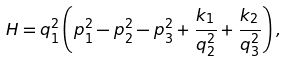Convert formula to latex. <formula><loc_0><loc_0><loc_500><loc_500>H = q _ { 1 } ^ { 2 } \left ( p _ { 1 } ^ { 2 } - p _ { 2 } ^ { 2 } - p _ { 3 } ^ { 2 } + \frac { k _ { 1 } } { q _ { 2 } ^ { 2 } } + \frac { k _ { 2 } } { q _ { 3 } ^ { 2 } } \right ) ,</formula> 